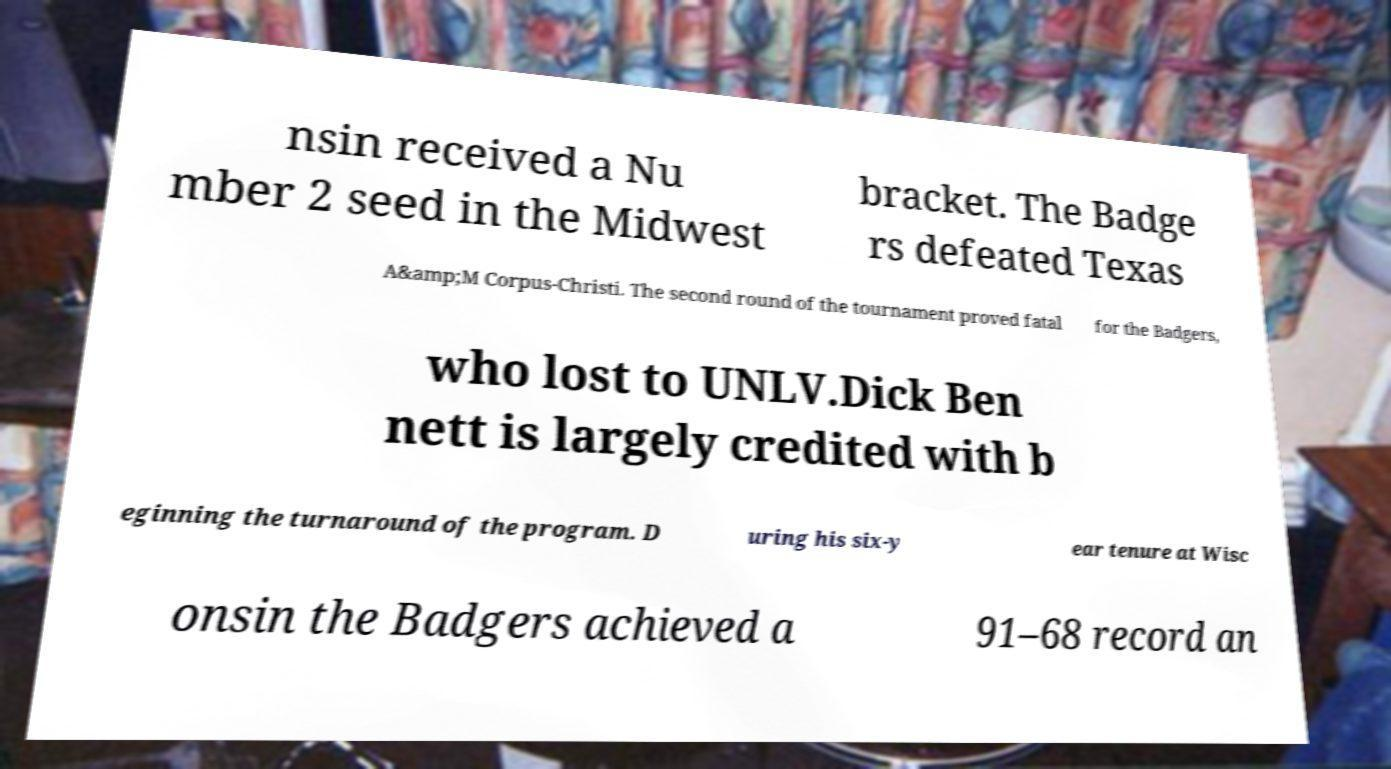There's text embedded in this image that I need extracted. Can you transcribe it verbatim? nsin received a Nu mber 2 seed in the Midwest bracket. The Badge rs defeated Texas A&amp;M Corpus-Christi. The second round of the tournament proved fatal for the Badgers, who lost to UNLV.Dick Ben nett is largely credited with b eginning the turnaround of the program. D uring his six-y ear tenure at Wisc onsin the Badgers achieved a 91–68 record an 